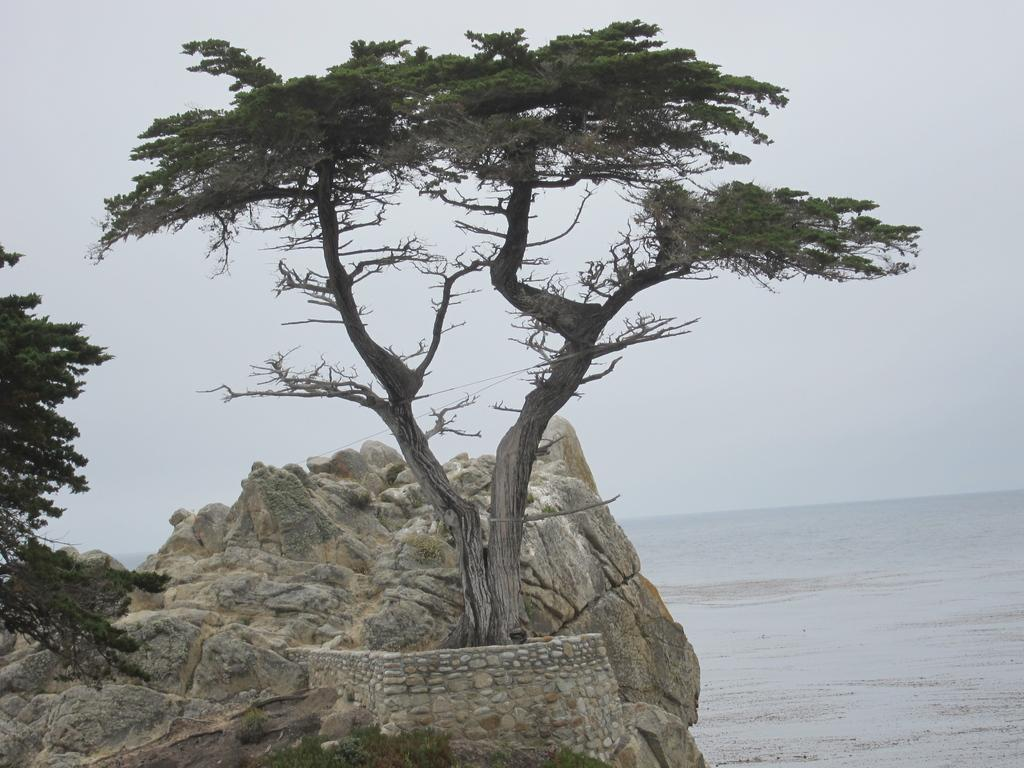What can be seen on the right side of the image? There is water on the right side of the image. What other objects or features are present in the image? There is a rock and trees in the image. What is visible in the sky in the image? There are clouds in the sky in the image. Are there any children wearing jeans in the image? There is no mention of children or jeans in the image; it features water, a rock, trees, and clouds. Can you see any scissors in the image? There is no mention of scissors in the image; it features water, a rock, trees, and clouds. 